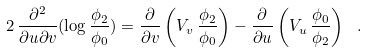Convert formula to latex. <formula><loc_0><loc_0><loc_500><loc_500>2 \, \frac { \partial ^ { 2 } } { \partial u \partial v } ( \log \frac { \phi _ { 2 } } { \phi _ { 0 } } ) = \frac { \partial } { \partial v } \left ( V _ { v } \, \frac { \phi _ { 2 } } { \phi _ { 0 } } \right ) - \frac { \partial } { \partial u } \left ( V _ { u } \, \frac { \phi _ { 0 } } { \phi _ { 2 } } \right ) \ .</formula> 